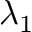Convert formula to latex. <formula><loc_0><loc_0><loc_500><loc_500>\lambda _ { 1 }</formula> 